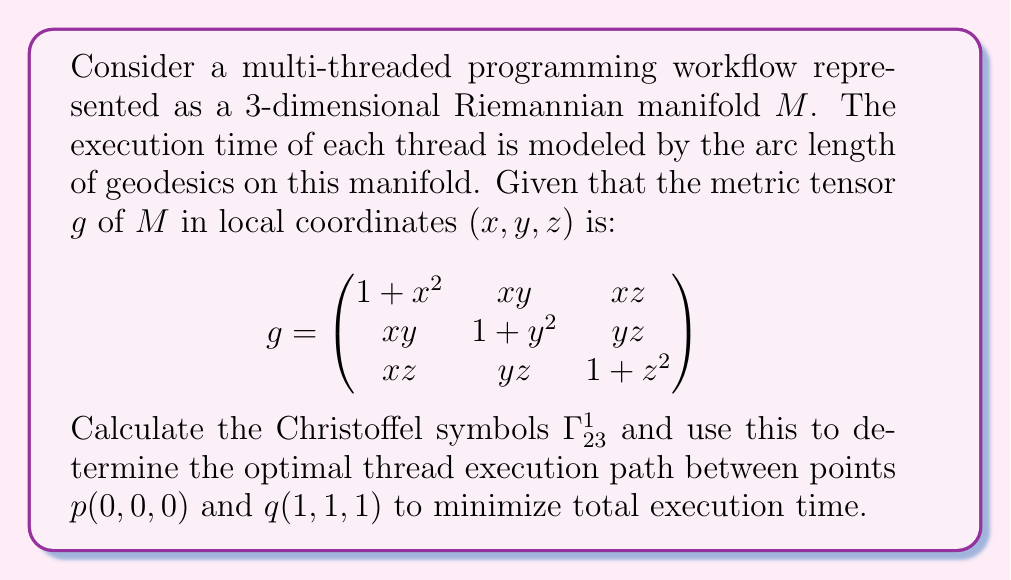Solve this math problem. To solve this problem, we need to follow these steps:

1) First, we need to calculate the Christoffel symbols. The formula for Christoffel symbols is:

   $$\Gamma^k_{ij} = \frac{1}{2}g^{km}(\frac{\partial g_{mj}}{\partial x^i} + \frac{\partial g_{mi}}{\partial x^j} - \frac{\partial g_{ij}}{\partial x^m})$$

2) We're asked to calculate $\Gamma^1_{23}$, so we need to find:

   $$\Gamma^1_{23} = \frac{1}{2}g^{1m}(\frac{\partial g_{m3}}{\partial x^2} + \frac{\partial g_{m2}}{\partial x^3} - \frac{\partial g_{23}}{\partial x^m})$$

3) To find $g^{1m}$, we need to invert the metric tensor. The inverse of $g$ is:

   $$g^{-1} = \frac{1}{det(g)}\begin{pmatrix}
   (1+y^2)(1+z^2)-y^2z^2 & -xy(1+z^2)+xyz^2 & -xz(1+y^2)+xy^2z \\
   -xy(1+z^2)+xyz^2 & (1+x^2)(1+z^2)-x^2z^2 & -yz(1+x^2)+x^2yz \\
   -xz(1+y^2)+xy^2z & -yz(1+x^2)+x^2yz & (1+x^2)(1+y^2)-x^2y^2
   \end{pmatrix}$$

4) Now, we can calculate:

   $$\frac{\partial g_{23}}{\partial x^1} = \frac{\partial (yz)}{\partial x} = 0$$
   $$\frac{\partial g_{13}}{\partial x^2} = \frac{\partial (xz)}{\partial y} = 0$$
   $$\frac{\partial g_{12}}{\partial x^3} = \frac{\partial (xy)}{\partial z} = 0$$

5) Substituting these into the formula for $\Gamma^1_{23}$:

   $$\Gamma^1_{23} = \frac{1}{2}g^{11}(0 + 0 - 0) + \frac{1}{2}g^{12}(z + 0 - y) + \frac{1}{2}g^{13}(0 + y - z) = \frac{1}{2}g^{12}(z - y) + \frac{1}{2}g^{13}(y - z)$$

6) Substituting the values from the inverse metric tensor:

   $$\Gamma^1_{23} = \frac{1}{2}\frac{-xy(1+z^2)+xyz^2}{det(g)}(z - y) + \frac{1}{2}\frac{-xz(1+y^2)+xy^2z}{det(g)}(y - z)$$

7) To find the optimal thread execution path (geodesic), we would need to solve the geodesic equation:

   $$\frac{d^2x^k}{dt^2} + \Gamma^k_{ij}\frac{dx^i}{dt}\frac{dx^j}{dt} = 0$$

   This is a system of second-order differential equations, which generally requires numerical methods to solve.

8) The optimal path will be the geodesic connecting points $p(0,0,0)$ and $q(1,1,1)$. This path minimizes the total execution time as it minimizes the arc length on the manifold.
Answer: The Christoffel symbol $\Gamma^1_{23}$ is:

$$\Gamma^1_{23} = \frac{1}{2}\frac{-xy(1+z^2)+xyz^2}{det(g)}(z - y) + \frac{1}{2}\frac{-xz(1+y^2)+xy^2z}{det(g)}(y - z)$$

The optimal thread execution path is the geodesic connecting points $p(0,0,0)$ and $q(1,1,1)$, which can be found by solving the geodesic equation using the calculated Christoffel symbols. 